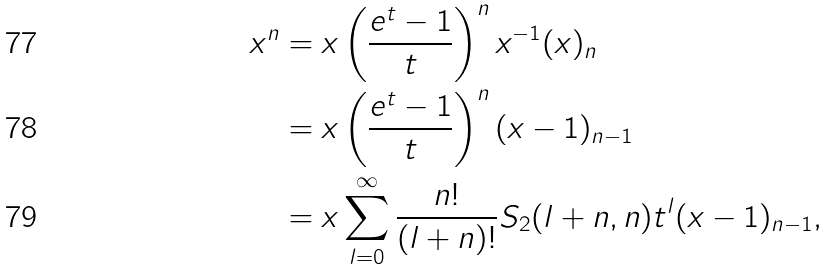<formula> <loc_0><loc_0><loc_500><loc_500>x ^ { n } & = x \left ( \frac { e ^ { t } - 1 } { t } \right ) ^ { n } x ^ { - 1 } ( x ) _ { n } \\ & = x \left ( \frac { e ^ { t } - 1 } { t } \right ) ^ { n } ( x - 1 ) _ { n - 1 } \\ & = x \sum _ { l = 0 } ^ { \infty } \frac { n ! } { ( l + n ) ! } S _ { 2 } ( l + n , n ) t ^ { l } ( x - 1 ) _ { n - 1 } ,</formula> 